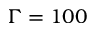Convert formula to latex. <formula><loc_0><loc_0><loc_500><loc_500>\Gamma = 1 0 0</formula> 